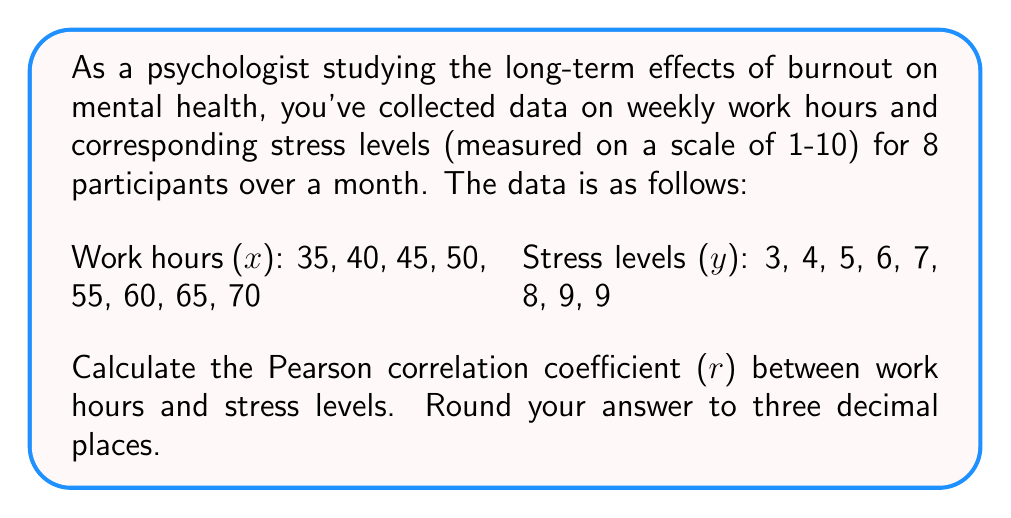Give your solution to this math problem. To calculate the Pearson correlation coefficient (r), we'll use the formula:

$$ r = \frac{n\sum xy - \sum x \sum y}{\sqrt{[n\sum x^2 - (\sum x)^2][n\sum y^2 - (\sum y)^2]}} $$

Where:
n = number of pairs of data
x = work hours
y = stress levels

Step 1: Calculate the required sums:
n = 8
$\sum x = 35 + 40 + 45 + 50 + 55 + 60 + 65 + 70 = 420$
$\sum y = 3 + 4 + 5 + 6 + 7 + 8 + 9 + 9 = 51$
$\sum xy = (35 \times 3) + (40 \times 4) + ... + (70 \times 9) = 2825$
$\sum x^2 = 35^2 + 40^2 + ... + 70^2 = 23450$
$\sum y^2 = 3^2 + 4^2 + ... + 9^2 = 351$

Step 2: Substitute these values into the formula:

$$ r = \frac{8(2825) - (420)(51)}{\sqrt{[8(23450) - 420^2][8(351) - 51^2]}} $$

Step 3: Simplify:

$$ r = \frac{22600 - 21420}{\sqrt{(187600 - 176400)(2808 - 2601)}} $$

$$ r = \frac{1180}{\sqrt{11200 \times 207}} $$

$$ r = \frac{1180}{\sqrt{2318400}} $$

$$ r = \frac{1180}{1522.63} $$

$$ r \approx 0.775 $$
Answer: 0.775 